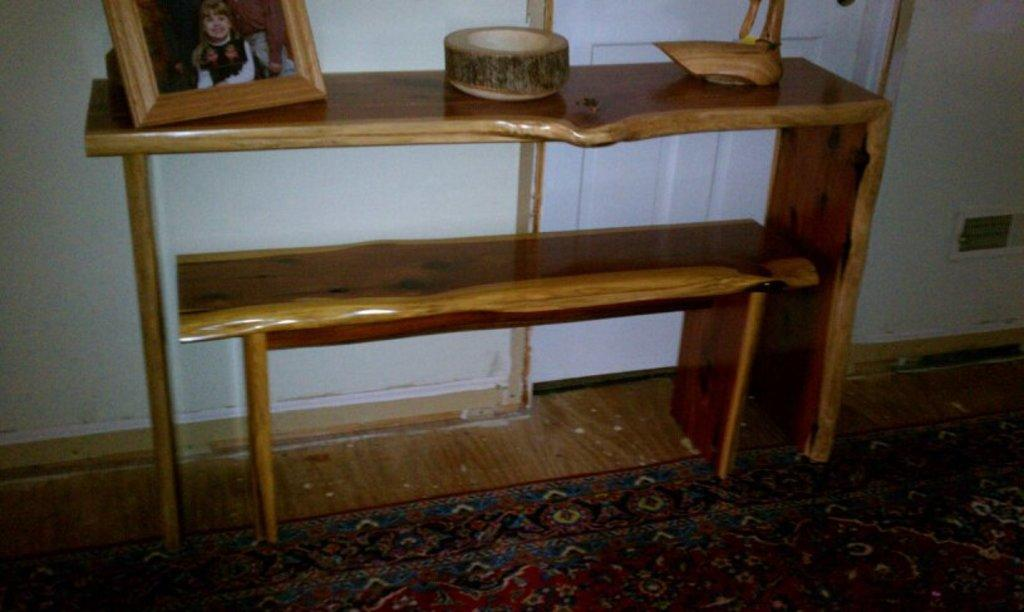What type of table is in the image? There is a wooden table in the image. What is on the table? A photo frame is present on the table, along with other things. Can you describe the background of the image? There is a door in the background of the image. What scent can be detected in the image? There is no information about a scent in the image, so it cannot be determined. 